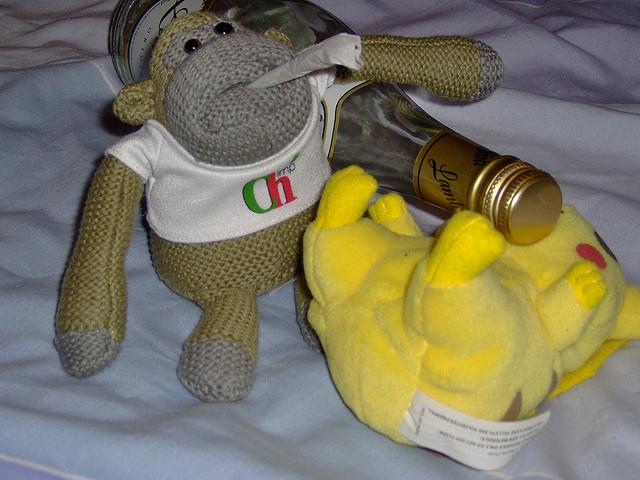What type of bottle is with the stuffed toys?
Quick response, please. Wine. What is the yellow stuff toy?
Give a very brief answer. Pikachu. What type of pokemon is Pikachu?
Be succinct. Yellow. 